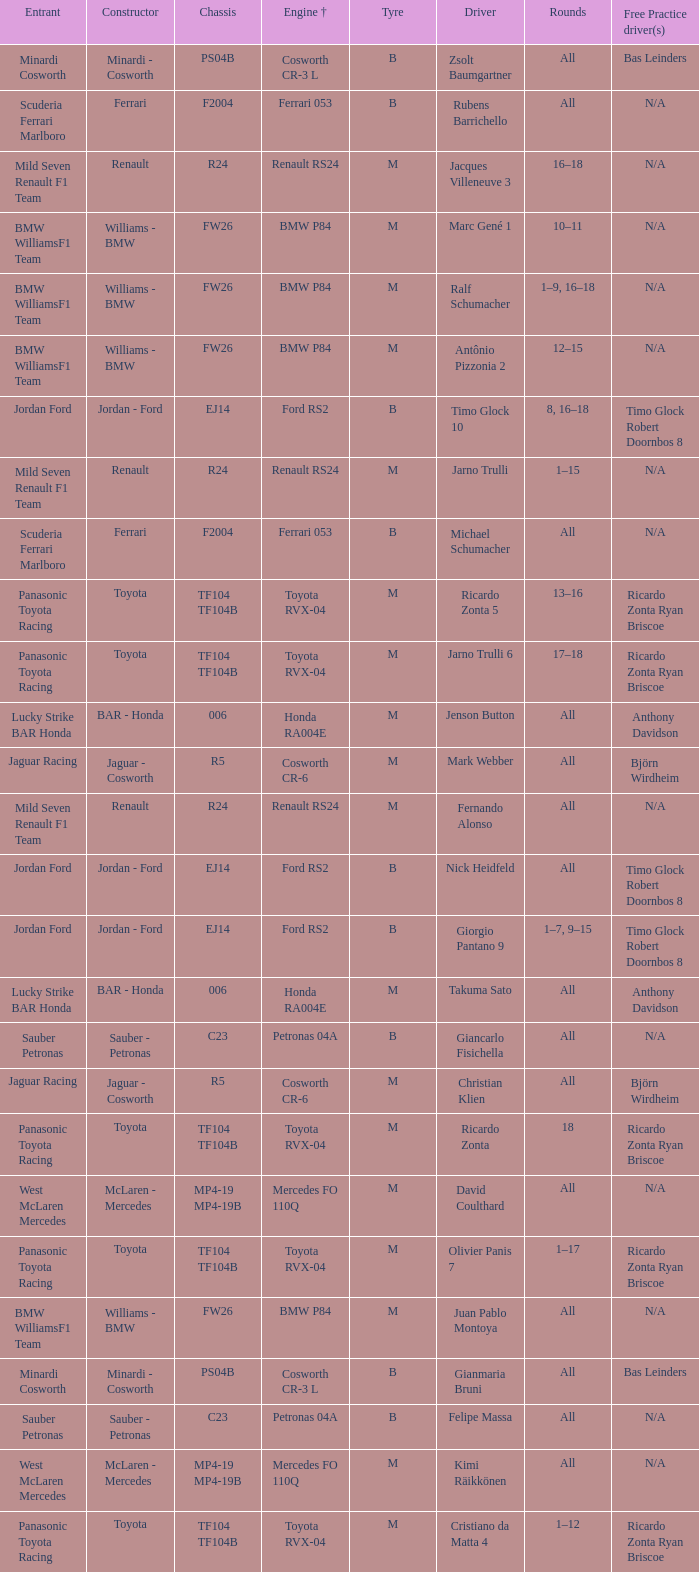What are the rounds for the B tyres and Ferrari 053 engine +? All, All. 